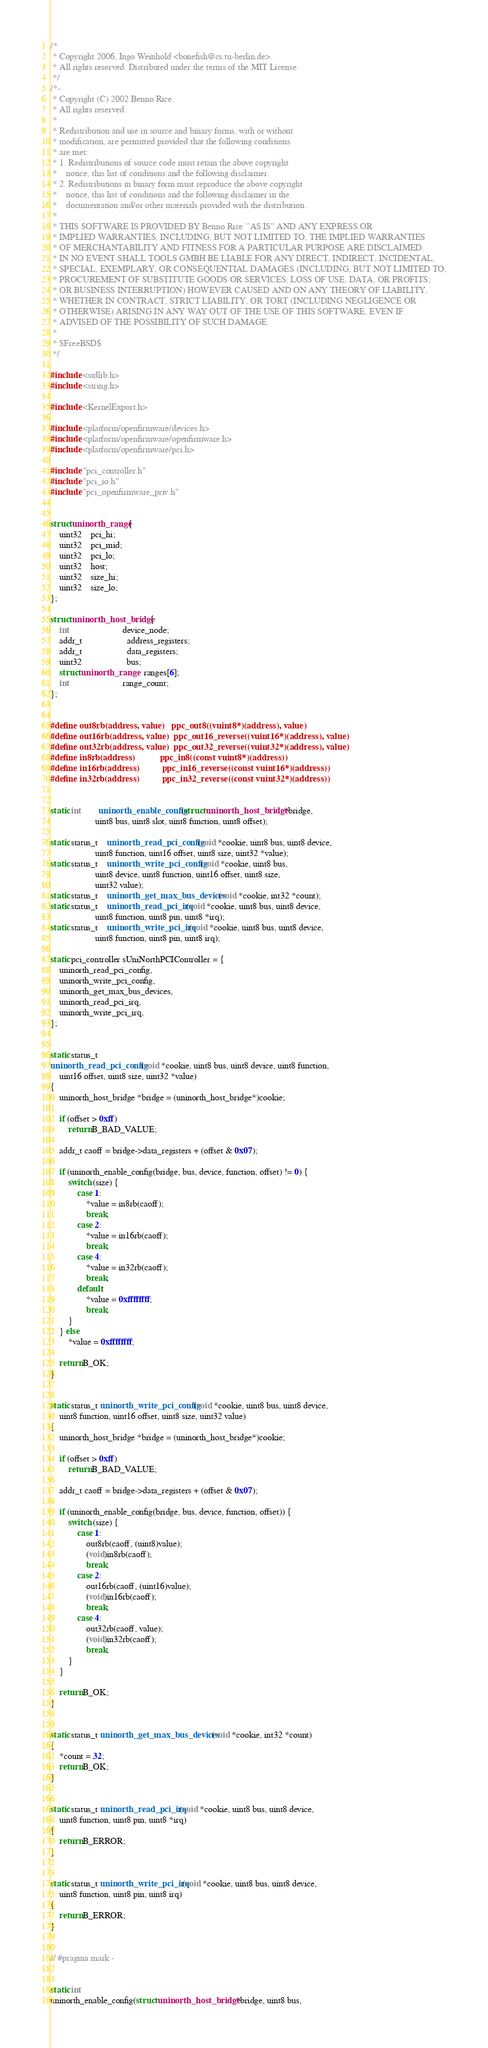<code> <loc_0><loc_0><loc_500><loc_500><_C++_>/*
 * Copyright 2006, Ingo Weinhold <bonefish@cs.tu-berlin.de>.
 * All rights reserved. Distributed under the terms of the MIT License.
 */
/*-
 * Copyright (C) 2002 Benno Rice.
 * All rights reserved.
 *
 * Redistribution and use in source and binary forms, with or without
 * modification, are permitted provided that the following conditions
 * are met:
 * 1. Redistributions of source code must retain the above copyright
 *    notice, this list of conditions and the following disclaimer.
 * 2. Redistributions in binary form must reproduce the above copyright
 *    notice, this list of conditions and the following disclaimer in the
 *    documentation and/or other materials provided with the distribution.
 *
 * THIS SOFTWARE IS PROVIDED BY Benno Rice ``AS IS'' AND ANY EXPRESS OR
 * IMPLIED WARRANTIES, INCLUDING, BUT NOT LIMITED TO, THE IMPLIED WARRANTIES
 * OF MERCHANTABILITY AND FITNESS FOR A PARTICULAR PURPOSE ARE DISCLAIMED.
 * IN NO EVENT SHALL TOOLS GMBH BE LIABLE FOR ANY DIRECT, INDIRECT, INCIDENTAL,
 * SPECIAL, EXEMPLARY, OR CONSEQUENTIAL DAMAGES (INCLUDING, BUT NOT LIMITED TO,
 * PROCUREMENT OF SUBSTITUTE GOODS OR SERVICES; LOSS OF USE, DATA, OR PROFITS;
 * OR BUSINESS INTERRUPTION) HOWEVER CAUSED AND ON ANY THEORY OF LIABILITY,
 * WHETHER IN CONTRACT, STRICT LIABILITY, OR TORT (INCLUDING NEGLIGENCE OR
 * OTHERWISE) ARISING IN ANY WAY OUT OF THE USE OF THIS SOFTWARE, EVEN IF
 * ADVISED OF THE POSSIBILITY OF SUCH DAMAGE.
 *
 * $FreeBSD$
 */

#include <stdlib.h>
#include <string.h>

#include <KernelExport.h>

#include <platform/openfirmware/devices.h>
#include <platform/openfirmware/openfirmware.h>
#include <platform/openfirmware/pci.h>

#include "pci_controller.h"
#include "pci_io.h"
#include "pci_openfirmware_priv.h"


struct uninorth_range {
	uint32	pci_hi;
	uint32	pci_mid;
	uint32	pci_lo;
	uint32	host;
	uint32	size_hi;
	uint32	size_lo;
};

struct uninorth_host_bridge {
	int						device_node;
	addr_t					address_registers;
	addr_t					data_registers;
	uint32					bus;
	struct uninorth_range	ranges[6];
	int						range_count;
};


#define out8rb(address, value)	ppc_out8((vuint8*)(address), value)
#define out16rb(address, value)	ppc_out16_reverse((vuint16*)(address), value)
#define out32rb(address, value)	ppc_out32_reverse((vuint32*)(address), value)
#define in8rb(address)			ppc_in8((const vuint8*)(address))
#define in16rb(address)			ppc_in16_reverse((const vuint16*)(address))
#define in32rb(address)			ppc_in32_reverse((const vuint32*)(address))


static int		uninorth_enable_config(struct uninorth_host_bridge *bridge,
					uint8 bus, uint8 slot, uint8 function, uint8 offset);

static status_t	uninorth_read_pci_config(void *cookie, uint8 bus, uint8 device,
					uint8 function, uint16 offset, uint8 size, uint32 *value);
static status_t	uninorth_write_pci_config(void *cookie, uint8 bus,
					uint8 device, uint8 function, uint16 offset, uint8 size,
					uint32 value);
static status_t	uninorth_get_max_bus_devices(void *cookie, int32 *count);
static status_t	uninorth_read_pci_irq(void *cookie, uint8 bus, uint8 device,
					uint8 function, uint8 pin, uint8 *irq);
static status_t	uninorth_write_pci_irq(void *cookie, uint8 bus, uint8 device,
					uint8 function, uint8 pin, uint8 irq);

static pci_controller sUniNorthPCIController = {
	uninorth_read_pci_config,
	uninorth_write_pci_config,
	uninorth_get_max_bus_devices,
	uninorth_read_pci_irq,
	uninorth_write_pci_irq,
};


static status_t
uninorth_read_pci_config(void *cookie, uint8 bus, uint8 device, uint8 function,
	uint16 offset, uint8 size, uint32 *value)
{
	uninorth_host_bridge *bridge = (uninorth_host_bridge*)cookie;

	if (offset > 0xff)
		return B_BAD_VALUE;

	addr_t caoff = bridge->data_registers + (offset & 0x07);

	if (uninorth_enable_config(bridge, bus, device, function, offset) != 0) {
		switch (size) {
			case 1:
				*value = in8rb(caoff);
				break;
			case 2:
				*value = in16rb(caoff);
				break;
			case 4:
				*value = in32rb(caoff);
				break;
			default:
				*value = 0xffffffff;
				break;
		}
	} else
		*value = 0xffffffff;

	return B_OK;
}


static status_t uninorth_write_pci_config(void *cookie, uint8 bus, uint8 device,
	uint8 function, uint16 offset, uint8 size, uint32 value)
{
	uninorth_host_bridge *bridge = (uninorth_host_bridge*)cookie;

	if (offset > 0xff)
		return B_BAD_VALUE;

	addr_t caoff = bridge->data_registers + (offset & 0x07);

	if (uninorth_enable_config(bridge, bus, device, function, offset)) {
		switch (size) {
			case 1:
				out8rb(caoff, (uint8)value);
				(void)in8rb(caoff);
				break;
			case 2:
				out16rb(caoff, (uint16)value);
				(void)in16rb(caoff);
				break;
			case 4:
				out32rb(caoff, value);
				(void)in32rb(caoff);
				break;
		}
	}

	return B_OK;
}


static status_t uninorth_get_max_bus_devices(void *cookie, int32 *count)
{
	*count = 32;
	return B_OK;
}


static status_t uninorth_read_pci_irq(void *cookie, uint8 bus, uint8 device,
	uint8 function, uint8 pin, uint8 *irq)
{
	return B_ERROR;
}


static status_t uninorth_write_pci_irq(void *cookie, uint8 bus, uint8 device,
	uint8 function, uint8 pin, uint8 irq)
{
	return B_ERROR;
}


// #pragma mark -


static int
uninorth_enable_config(struct uninorth_host_bridge *bridge, uint8 bus,</code> 